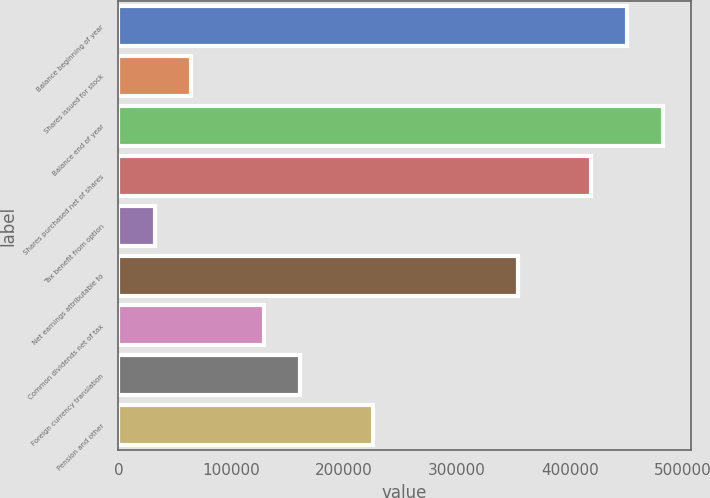Convert chart to OTSL. <chart><loc_0><loc_0><loc_500><loc_500><bar_chart><fcel>Balance beginning of year<fcel>Shares issued for stock<fcel>Balance end of year<fcel>Shares purchased net of shares<fcel>Tax benefit from option<fcel>Net earnings attributable to<fcel>Common dividends net of tax<fcel>Foreign currency translation<fcel>Pension and other<nl><fcel>450567<fcel>64367.1<fcel>482751<fcel>418384<fcel>32183.8<fcel>354017<fcel>128734<fcel>160917<fcel>225284<nl></chart> 